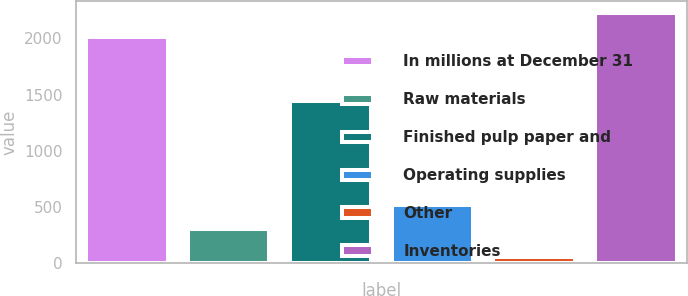Convert chart. <chart><loc_0><loc_0><loc_500><loc_500><bar_chart><fcel>In millions at December 31<fcel>Raw materials<fcel>Finished pulp paper and<fcel>Operating supplies<fcel>Other<fcel>Inventories<nl><fcel>2009<fcel>307<fcel>1443<fcel>519.7<fcel>52<fcel>2221.7<nl></chart> 